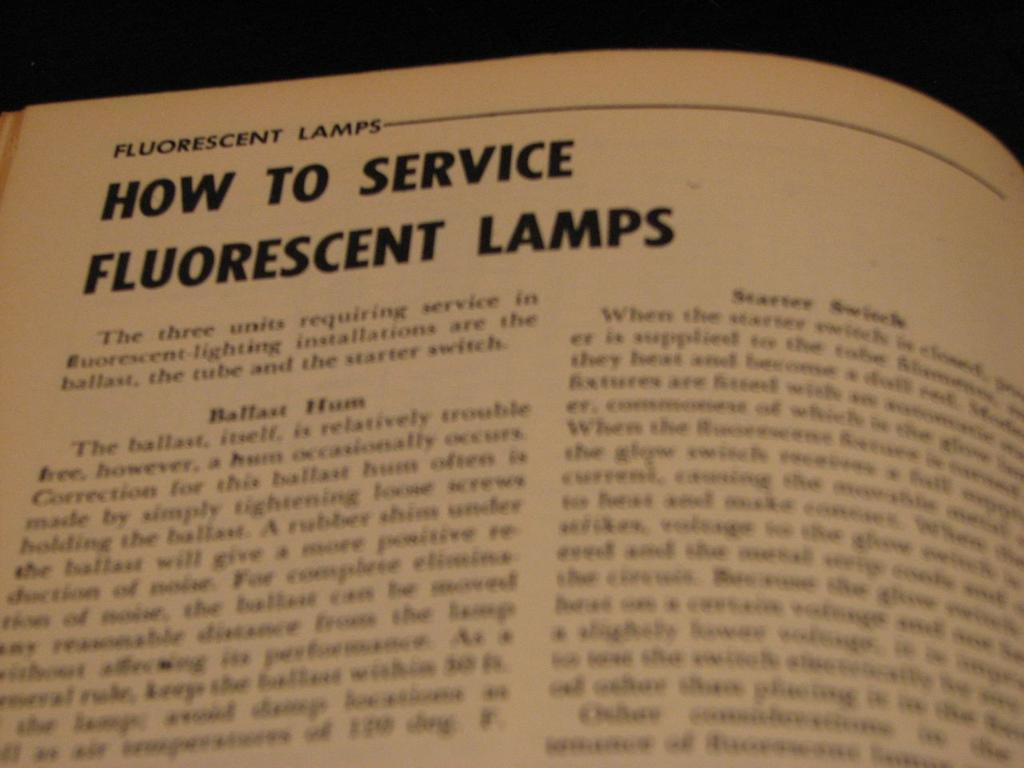<image>
Give a short and clear explanation of the subsequent image. A page in a book about How to Service Fluorescent Lamps 